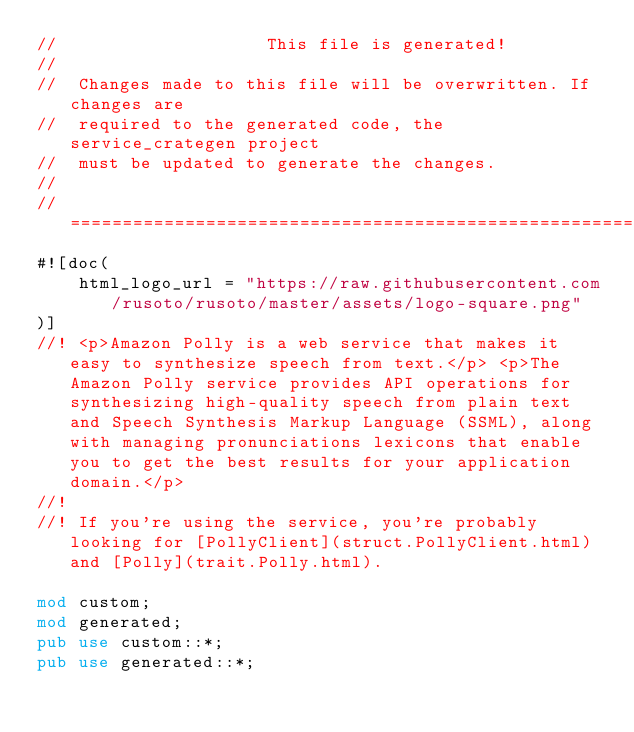Convert code to text. <code><loc_0><loc_0><loc_500><loc_500><_Rust_>//                    This file is generated!
//
//  Changes made to this file will be overwritten. If changes are
//  required to the generated code, the service_crategen project
//  must be updated to generate the changes.
//
// =================================================================
#![doc(
    html_logo_url = "https://raw.githubusercontent.com/rusoto/rusoto/master/assets/logo-square.png"
)]
//! <p>Amazon Polly is a web service that makes it easy to synthesize speech from text.</p> <p>The Amazon Polly service provides API operations for synthesizing high-quality speech from plain text and Speech Synthesis Markup Language (SSML), along with managing pronunciations lexicons that enable you to get the best results for your application domain.</p>
//!
//! If you're using the service, you're probably looking for [PollyClient](struct.PollyClient.html) and [Polly](trait.Polly.html).

mod custom;
mod generated;
pub use custom::*;
pub use generated::*;
</code> 